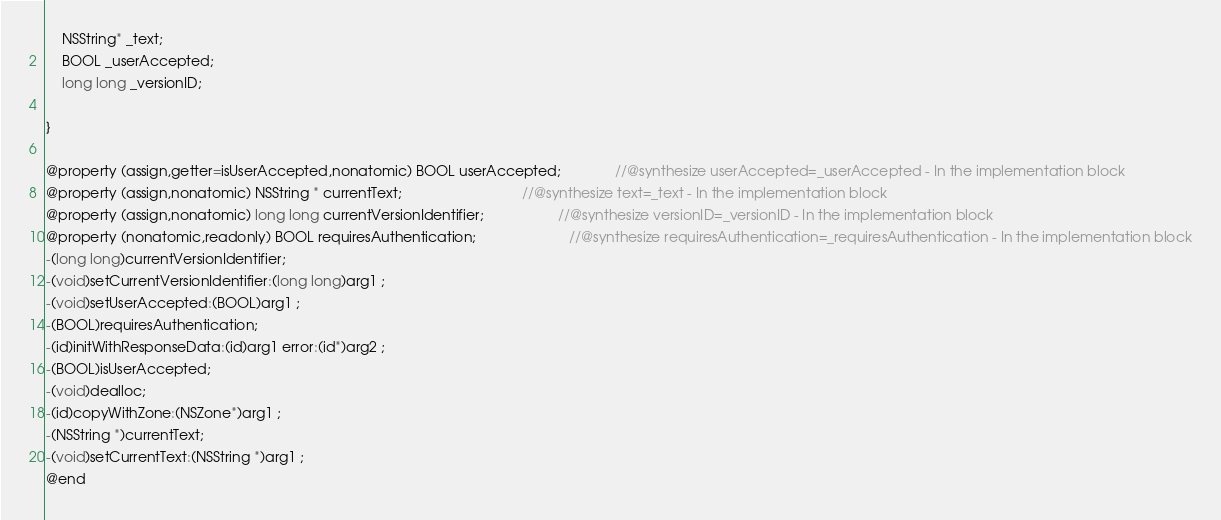Convert code to text. <code><loc_0><loc_0><loc_500><loc_500><_C_>	NSString* _text;
	BOOL _userAccepted;
	long long _versionID;

}

@property (assign,getter=isUserAccepted,nonatomic) BOOL userAccepted;              //@synthesize userAccepted=_userAccepted - In the implementation block
@property (assign,nonatomic) NSString * currentText;                               //@synthesize text=_text - In the implementation block
@property (assign,nonatomic) long long currentVersionIdentifier;                   //@synthesize versionID=_versionID - In the implementation block
@property (nonatomic,readonly) BOOL requiresAuthentication;                        //@synthesize requiresAuthentication=_requiresAuthentication - In the implementation block
-(long long)currentVersionIdentifier;
-(void)setCurrentVersionIdentifier:(long long)arg1 ;
-(void)setUserAccepted:(BOOL)arg1 ;
-(BOOL)requiresAuthentication;
-(id)initWithResponseData:(id)arg1 error:(id*)arg2 ;
-(BOOL)isUserAccepted;
-(void)dealloc;
-(id)copyWithZone:(NSZone*)arg1 ;
-(NSString *)currentText;
-(void)setCurrentText:(NSString *)arg1 ;
@end

</code> 